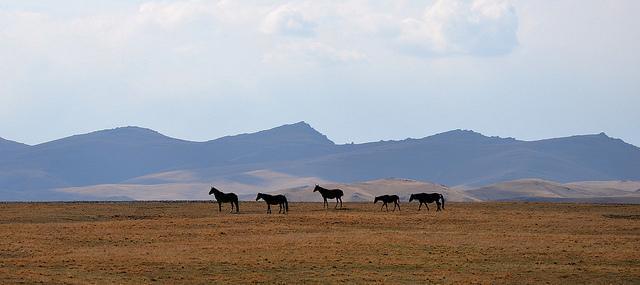How many horses are running?
Give a very brief answer. 0. How many horses can you see?
Give a very brief answer. 5. How many horses are there?
Give a very brief answer. 5. How many horses are in the field?
Give a very brief answer. 5. How many pieces of litter are on the ground?
Give a very brief answer. 0. 